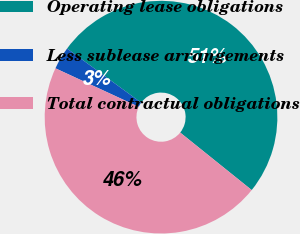<chart> <loc_0><loc_0><loc_500><loc_500><pie_chart><fcel>Operating lease obligations<fcel>Less sublease arrangements<fcel>Total contractual obligations<nl><fcel>50.74%<fcel>3.14%<fcel>46.12%<nl></chart> 